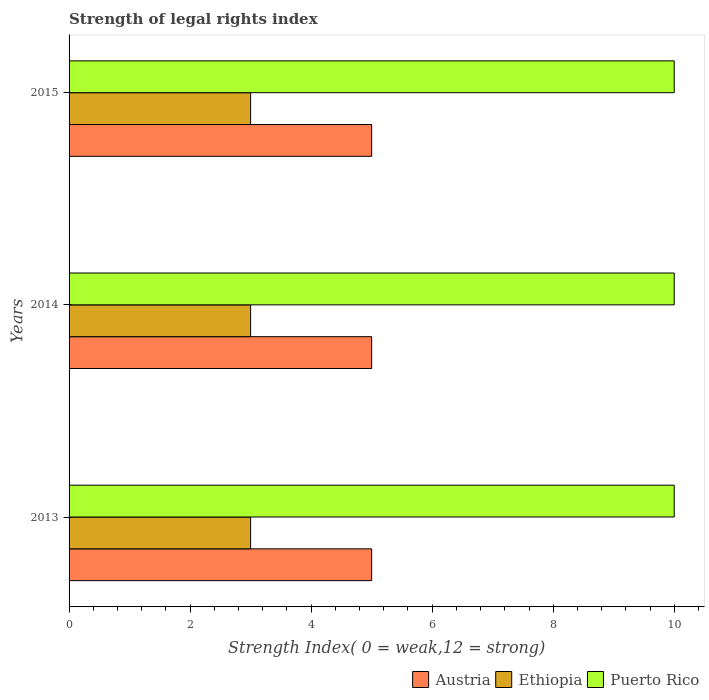How many bars are there on the 1st tick from the bottom?
Offer a very short reply. 3. What is the label of the 2nd group of bars from the top?
Your answer should be very brief. 2014. What is the strength index in Puerto Rico in 2015?
Give a very brief answer. 10. Across all years, what is the maximum strength index in Ethiopia?
Offer a very short reply. 3. Across all years, what is the minimum strength index in Austria?
Provide a succinct answer. 5. In which year was the strength index in Ethiopia maximum?
Your answer should be very brief. 2013. In which year was the strength index in Austria minimum?
Your answer should be compact. 2013. What is the total strength index in Ethiopia in the graph?
Your response must be concise. 9. What is the difference between the strength index in Ethiopia in 2014 and the strength index in Puerto Rico in 2015?
Ensure brevity in your answer.  -7. What is the average strength index in Austria per year?
Offer a very short reply. 5. In the year 2015, what is the difference between the strength index in Austria and strength index in Puerto Rico?
Your answer should be very brief. -5. In how many years, is the strength index in Ethiopia greater than 3.2 ?
Provide a short and direct response. 0. What is the difference between the highest and the lowest strength index in Puerto Rico?
Ensure brevity in your answer.  0. In how many years, is the strength index in Puerto Rico greater than the average strength index in Puerto Rico taken over all years?
Your answer should be very brief. 0. Is the sum of the strength index in Puerto Rico in 2014 and 2015 greater than the maximum strength index in Austria across all years?
Provide a short and direct response. Yes. What does the 3rd bar from the bottom in 2014 represents?
Provide a short and direct response. Puerto Rico. How many bars are there?
Provide a succinct answer. 9. How many legend labels are there?
Your answer should be compact. 3. What is the title of the graph?
Make the answer very short. Strength of legal rights index. Does "Uzbekistan" appear as one of the legend labels in the graph?
Your answer should be compact. No. What is the label or title of the X-axis?
Keep it short and to the point. Strength Index( 0 = weak,12 = strong). What is the Strength Index( 0 = weak,12 = strong) of Austria in 2013?
Offer a terse response. 5. What is the Strength Index( 0 = weak,12 = strong) in Puerto Rico in 2013?
Your response must be concise. 10. What is the Strength Index( 0 = weak,12 = strong) of Austria in 2014?
Keep it short and to the point. 5. What is the Strength Index( 0 = weak,12 = strong) of Ethiopia in 2014?
Keep it short and to the point. 3. What is the Strength Index( 0 = weak,12 = strong) of Puerto Rico in 2014?
Provide a succinct answer. 10. What is the Strength Index( 0 = weak,12 = strong) of Austria in 2015?
Offer a terse response. 5. Across all years, what is the maximum Strength Index( 0 = weak,12 = strong) in Ethiopia?
Your answer should be compact. 3. Across all years, what is the maximum Strength Index( 0 = weak,12 = strong) of Puerto Rico?
Keep it short and to the point. 10. Across all years, what is the minimum Strength Index( 0 = weak,12 = strong) of Austria?
Provide a short and direct response. 5. Across all years, what is the minimum Strength Index( 0 = weak,12 = strong) in Ethiopia?
Ensure brevity in your answer.  3. What is the total Strength Index( 0 = weak,12 = strong) in Austria in the graph?
Give a very brief answer. 15. What is the total Strength Index( 0 = weak,12 = strong) in Puerto Rico in the graph?
Provide a short and direct response. 30. What is the difference between the Strength Index( 0 = weak,12 = strong) in Austria in 2013 and that in 2014?
Provide a succinct answer. 0. What is the difference between the Strength Index( 0 = weak,12 = strong) in Ethiopia in 2013 and that in 2015?
Provide a succinct answer. 0. What is the difference between the Strength Index( 0 = weak,12 = strong) of Puerto Rico in 2013 and that in 2015?
Your response must be concise. 0. What is the difference between the Strength Index( 0 = weak,12 = strong) in Austria in 2014 and that in 2015?
Give a very brief answer. 0. What is the difference between the Strength Index( 0 = weak,12 = strong) in Ethiopia in 2014 and that in 2015?
Make the answer very short. 0. What is the difference between the Strength Index( 0 = weak,12 = strong) of Puerto Rico in 2014 and that in 2015?
Your answer should be very brief. 0. What is the difference between the Strength Index( 0 = weak,12 = strong) in Austria in 2013 and the Strength Index( 0 = weak,12 = strong) in Ethiopia in 2014?
Your response must be concise. 2. What is the difference between the Strength Index( 0 = weak,12 = strong) in Austria in 2013 and the Strength Index( 0 = weak,12 = strong) in Puerto Rico in 2014?
Provide a succinct answer. -5. What is the difference between the Strength Index( 0 = weak,12 = strong) of Ethiopia in 2013 and the Strength Index( 0 = weak,12 = strong) of Puerto Rico in 2014?
Offer a terse response. -7. What is the difference between the Strength Index( 0 = weak,12 = strong) of Austria in 2013 and the Strength Index( 0 = weak,12 = strong) of Ethiopia in 2015?
Provide a short and direct response. 2. What is the difference between the Strength Index( 0 = weak,12 = strong) of Austria in 2013 and the Strength Index( 0 = weak,12 = strong) of Puerto Rico in 2015?
Your answer should be very brief. -5. What is the difference between the Strength Index( 0 = weak,12 = strong) in Austria in 2014 and the Strength Index( 0 = weak,12 = strong) in Ethiopia in 2015?
Your answer should be compact. 2. What is the difference between the Strength Index( 0 = weak,12 = strong) of Austria in 2014 and the Strength Index( 0 = weak,12 = strong) of Puerto Rico in 2015?
Your answer should be very brief. -5. What is the average Strength Index( 0 = weak,12 = strong) in Austria per year?
Your answer should be very brief. 5. What is the average Strength Index( 0 = weak,12 = strong) of Puerto Rico per year?
Provide a short and direct response. 10. In the year 2013, what is the difference between the Strength Index( 0 = weak,12 = strong) in Ethiopia and Strength Index( 0 = weak,12 = strong) in Puerto Rico?
Make the answer very short. -7. In the year 2014, what is the difference between the Strength Index( 0 = weak,12 = strong) of Austria and Strength Index( 0 = weak,12 = strong) of Puerto Rico?
Give a very brief answer. -5. In the year 2015, what is the difference between the Strength Index( 0 = weak,12 = strong) of Austria and Strength Index( 0 = weak,12 = strong) of Puerto Rico?
Your answer should be very brief. -5. What is the ratio of the Strength Index( 0 = weak,12 = strong) in Austria in 2013 to that in 2015?
Provide a short and direct response. 1. What is the ratio of the Strength Index( 0 = weak,12 = strong) of Ethiopia in 2013 to that in 2015?
Offer a terse response. 1. What is the difference between the highest and the second highest Strength Index( 0 = weak,12 = strong) of Puerto Rico?
Provide a short and direct response. 0. What is the difference between the highest and the lowest Strength Index( 0 = weak,12 = strong) of Puerto Rico?
Provide a short and direct response. 0. 